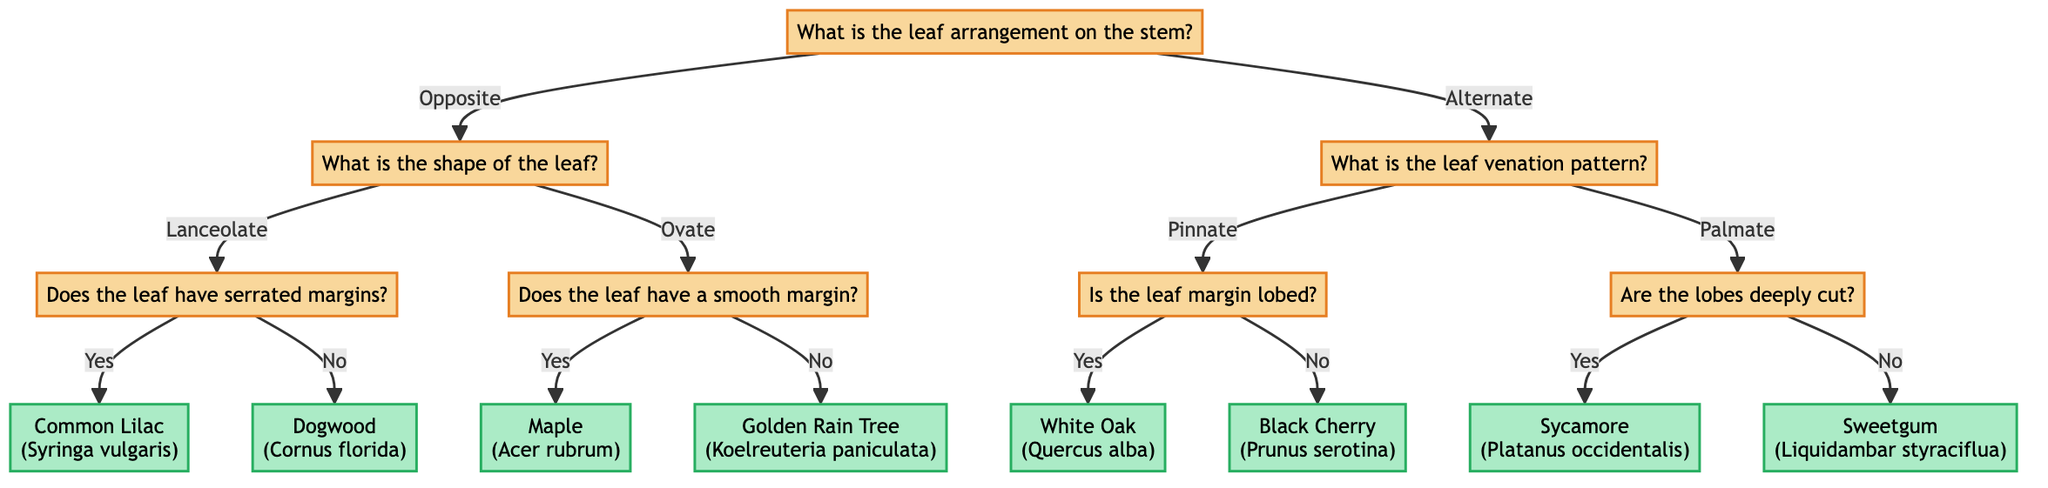What is the first question at the root of the decision tree? The root question is about the leaf arrangement on the stem, which is the starting point for the identification process.
Answer: What is the leaf arrangement on the stem? What is the species identified if the leaf arrangement is opposite, the shape is lanceolate, and the margins are serrated? Following the decision tree, if the leaf arrangement is opposite, we move to the shape question and identify lanceolate; then, the next question checks for serrated margins. If the answer is yes, the species is identified as Common Lilac.
Answer: Common Lilac (Syringa vulgaris) How many ultimate leaf species are identified in this decision tree? Counting the leaf species nodes at the end of the tree, we find a total of 8 species listed (each connected from their respective questions).
Answer: 8 If the leaf arrangement is alternate and the venation pattern is palmate with deeply cut lobes, what is the resulting species? Starting with an alternate arrangement leads us to the venation pattern question; if the answer is palmate, we then ask about lobes. If the lobes are deeply cut, the species identified is Sycamore.
Answer: Sycamore (Platanus occidentalis) What question is asked after determining that the leaf arrangement is alternate? After determining the leaf arrangement is alternate, the tree directs us to the question regarding the leaf venation pattern next.
Answer: What is the leaf venation pattern? What does a 'yes' answer lead to when asking if the leaf margin is lobed, given an alternate leaf arrangement with a pinnate venation? If beginning with an alternate arrangement and a pinnate venation pattern, answering 'yes' to the lobed margin question identifies the species as White Oak.
Answer: White Oak (Quercus alba) What shape of the leaf corresponds with a 'no' answer to having a smooth margin when the arrangement is opposite? Following the path for an opposite arrangement and determining that the leaf shape is ovate, the question for the margin results in a 'no' answer, identifying the species as Golden Rain Tree.
Answer: Golden Rain Tree (Koelreuteria paniculata) What happens if the leaf arrangement is alternate and the leaf venation is pinnate with a 'no' answer on the lobed margin? Starting with an alternate arrangement, if the leaf venation is pinnate and you answer 'no' to the lobed margin question, the species identified will be Black Cherry.
Answer: Black Cherry (Prunus serotina) 